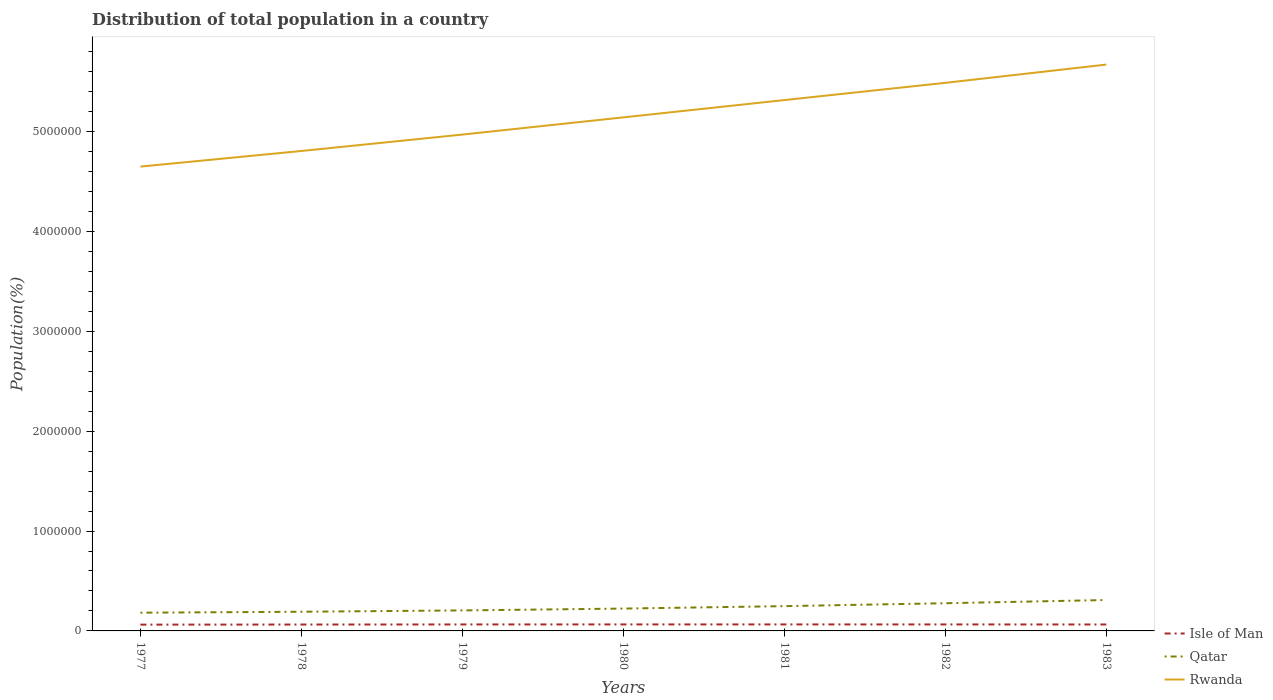How many different coloured lines are there?
Your answer should be very brief. 3. Is the number of lines equal to the number of legend labels?
Offer a terse response. Yes. Across all years, what is the maximum population of in Qatar?
Give a very brief answer. 1.82e+05. In which year was the population of in Qatar maximum?
Your response must be concise. 1977. What is the total population of in Isle of Man in the graph?
Ensure brevity in your answer.  -486. What is the difference between the highest and the second highest population of in Qatar?
Ensure brevity in your answer.  1.27e+05. What is the difference between the highest and the lowest population of in Qatar?
Your answer should be compact. 3. Is the population of in Isle of Man strictly greater than the population of in Qatar over the years?
Your answer should be very brief. Yes. How many years are there in the graph?
Offer a very short reply. 7. Are the values on the major ticks of Y-axis written in scientific E-notation?
Offer a terse response. No. Does the graph contain any zero values?
Offer a terse response. No. Where does the legend appear in the graph?
Provide a short and direct response. Bottom right. How many legend labels are there?
Offer a very short reply. 3. What is the title of the graph?
Your answer should be compact. Distribution of total population in a country. Does "Cote d'Ivoire" appear as one of the legend labels in the graph?
Offer a very short reply. No. What is the label or title of the Y-axis?
Your answer should be compact. Population(%). What is the Population(%) of Isle of Man in 1977?
Give a very brief answer. 6.29e+04. What is the Population(%) of Qatar in 1977?
Your answer should be compact. 1.82e+05. What is the Population(%) in Rwanda in 1977?
Make the answer very short. 4.65e+06. What is the Population(%) of Isle of Man in 1978?
Ensure brevity in your answer.  6.39e+04. What is the Population(%) of Qatar in 1978?
Provide a short and direct response. 1.92e+05. What is the Population(%) of Rwanda in 1978?
Ensure brevity in your answer.  4.80e+06. What is the Population(%) of Isle of Man in 1979?
Make the answer very short. 6.47e+04. What is the Population(%) of Qatar in 1979?
Your response must be concise. 2.05e+05. What is the Population(%) of Rwanda in 1979?
Ensure brevity in your answer.  4.97e+06. What is the Population(%) in Isle of Man in 1980?
Make the answer very short. 6.51e+04. What is the Population(%) of Qatar in 1980?
Keep it short and to the point. 2.24e+05. What is the Population(%) of Rwanda in 1980?
Make the answer very short. 5.14e+06. What is the Population(%) of Isle of Man in 1981?
Give a very brief answer. 6.51e+04. What is the Population(%) in Qatar in 1981?
Ensure brevity in your answer.  2.48e+05. What is the Population(%) of Rwanda in 1981?
Make the answer very short. 5.31e+06. What is the Population(%) in Isle of Man in 1982?
Your response must be concise. 6.48e+04. What is the Population(%) in Qatar in 1982?
Your answer should be compact. 2.77e+05. What is the Population(%) of Rwanda in 1982?
Your response must be concise. 5.49e+06. What is the Population(%) of Isle of Man in 1983?
Offer a terse response. 6.44e+04. What is the Population(%) of Qatar in 1983?
Offer a very short reply. 3.09e+05. What is the Population(%) of Rwanda in 1983?
Offer a very short reply. 5.67e+06. Across all years, what is the maximum Population(%) in Isle of Man?
Provide a succinct answer. 6.51e+04. Across all years, what is the maximum Population(%) of Qatar?
Keep it short and to the point. 3.09e+05. Across all years, what is the maximum Population(%) in Rwanda?
Your answer should be compact. 5.67e+06. Across all years, what is the minimum Population(%) in Isle of Man?
Keep it short and to the point. 6.29e+04. Across all years, what is the minimum Population(%) in Qatar?
Your answer should be very brief. 1.82e+05. Across all years, what is the minimum Population(%) of Rwanda?
Offer a very short reply. 4.65e+06. What is the total Population(%) of Isle of Man in the graph?
Offer a terse response. 4.51e+05. What is the total Population(%) in Qatar in the graph?
Keep it short and to the point. 1.64e+06. What is the total Population(%) in Rwanda in the graph?
Provide a succinct answer. 3.60e+07. What is the difference between the Population(%) of Isle of Man in 1977 and that in 1978?
Make the answer very short. -984. What is the difference between the Population(%) in Qatar in 1977 and that in 1978?
Provide a succinct answer. -9648. What is the difference between the Population(%) of Rwanda in 1977 and that in 1978?
Make the answer very short. -1.56e+05. What is the difference between the Population(%) of Isle of Man in 1977 and that in 1979?
Provide a succinct answer. -1746. What is the difference between the Population(%) in Qatar in 1977 and that in 1979?
Give a very brief answer. -2.29e+04. What is the difference between the Population(%) in Rwanda in 1977 and that in 1979?
Your answer should be compact. -3.21e+05. What is the difference between the Population(%) of Isle of Man in 1977 and that in 1980?
Offer a very short reply. -2174. What is the difference between the Population(%) in Qatar in 1977 and that in 1980?
Your answer should be compact. -4.13e+04. What is the difference between the Population(%) in Rwanda in 1977 and that in 1980?
Your answer should be compact. -4.93e+05. What is the difference between the Population(%) of Isle of Man in 1977 and that in 1981?
Make the answer very short. -2194. What is the difference between the Population(%) of Qatar in 1977 and that in 1981?
Your answer should be very brief. -6.57e+04. What is the difference between the Population(%) of Rwanda in 1977 and that in 1981?
Offer a terse response. -6.66e+05. What is the difference between the Population(%) in Isle of Man in 1977 and that in 1982?
Ensure brevity in your answer.  -1883. What is the difference between the Population(%) in Qatar in 1977 and that in 1982?
Provide a succinct answer. -9.49e+04. What is the difference between the Population(%) of Rwanda in 1977 and that in 1982?
Keep it short and to the point. -8.38e+05. What is the difference between the Population(%) in Isle of Man in 1977 and that in 1983?
Your response must be concise. -1470. What is the difference between the Population(%) in Qatar in 1977 and that in 1983?
Your answer should be very brief. -1.27e+05. What is the difference between the Population(%) in Rwanda in 1977 and that in 1983?
Provide a succinct answer. -1.02e+06. What is the difference between the Population(%) of Isle of Man in 1978 and that in 1979?
Give a very brief answer. -762. What is the difference between the Population(%) of Qatar in 1978 and that in 1979?
Provide a short and direct response. -1.32e+04. What is the difference between the Population(%) in Rwanda in 1978 and that in 1979?
Your answer should be compact. -1.64e+05. What is the difference between the Population(%) in Isle of Man in 1978 and that in 1980?
Offer a very short reply. -1190. What is the difference between the Population(%) of Qatar in 1978 and that in 1980?
Your response must be concise. -3.17e+04. What is the difference between the Population(%) of Rwanda in 1978 and that in 1980?
Keep it short and to the point. -3.36e+05. What is the difference between the Population(%) in Isle of Man in 1978 and that in 1981?
Make the answer very short. -1210. What is the difference between the Population(%) in Qatar in 1978 and that in 1981?
Offer a very short reply. -5.60e+04. What is the difference between the Population(%) in Rwanda in 1978 and that in 1981?
Offer a very short reply. -5.10e+05. What is the difference between the Population(%) of Isle of Man in 1978 and that in 1982?
Offer a terse response. -899. What is the difference between the Population(%) in Qatar in 1978 and that in 1982?
Make the answer very short. -8.52e+04. What is the difference between the Population(%) of Rwanda in 1978 and that in 1982?
Your answer should be compact. -6.82e+05. What is the difference between the Population(%) of Isle of Man in 1978 and that in 1983?
Offer a terse response. -486. What is the difference between the Population(%) of Qatar in 1978 and that in 1983?
Your response must be concise. -1.17e+05. What is the difference between the Population(%) of Rwanda in 1978 and that in 1983?
Keep it short and to the point. -8.65e+05. What is the difference between the Population(%) of Isle of Man in 1979 and that in 1980?
Offer a terse response. -428. What is the difference between the Population(%) of Qatar in 1979 and that in 1980?
Your answer should be very brief. -1.85e+04. What is the difference between the Population(%) of Rwanda in 1979 and that in 1980?
Give a very brief answer. -1.72e+05. What is the difference between the Population(%) of Isle of Man in 1979 and that in 1981?
Offer a terse response. -448. What is the difference between the Population(%) of Qatar in 1979 and that in 1981?
Provide a succinct answer. -4.28e+04. What is the difference between the Population(%) of Rwanda in 1979 and that in 1981?
Your answer should be very brief. -3.45e+05. What is the difference between the Population(%) in Isle of Man in 1979 and that in 1982?
Provide a succinct answer. -137. What is the difference between the Population(%) of Qatar in 1979 and that in 1982?
Offer a terse response. -7.20e+04. What is the difference between the Population(%) in Rwanda in 1979 and that in 1982?
Offer a very short reply. -5.18e+05. What is the difference between the Population(%) in Isle of Man in 1979 and that in 1983?
Your response must be concise. 276. What is the difference between the Population(%) of Qatar in 1979 and that in 1983?
Provide a succinct answer. -1.04e+05. What is the difference between the Population(%) of Rwanda in 1979 and that in 1983?
Make the answer very short. -7.01e+05. What is the difference between the Population(%) of Qatar in 1980 and that in 1981?
Offer a terse response. -2.43e+04. What is the difference between the Population(%) of Rwanda in 1980 and that in 1981?
Provide a succinct answer. -1.73e+05. What is the difference between the Population(%) of Isle of Man in 1980 and that in 1982?
Offer a terse response. 291. What is the difference between the Population(%) of Qatar in 1980 and that in 1982?
Give a very brief answer. -5.35e+04. What is the difference between the Population(%) in Rwanda in 1980 and that in 1982?
Give a very brief answer. -3.46e+05. What is the difference between the Population(%) in Isle of Man in 1980 and that in 1983?
Keep it short and to the point. 704. What is the difference between the Population(%) in Qatar in 1980 and that in 1983?
Offer a terse response. -8.56e+04. What is the difference between the Population(%) of Rwanda in 1980 and that in 1983?
Ensure brevity in your answer.  -5.28e+05. What is the difference between the Population(%) in Isle of Man in 1981 and that in 1982?
Provide a succinct answer. 311. What is the difference between the Population(%) of Qatar in 1981 and that in 1982?
Offer a very short reply. -2.92e+04. What is the difference between the Population(%) in Rwanda in 1981 and that in 1982?
Your response must be concise. -1.73e+05. What is the difference between the Population(%) in Isle of Man in 1981 and that in 1983?
Provide a short and direct response. 724. What is the difference between the Population(%) of Qatar in 1981 and that in 1983?
Your answer should be compact. -6.12e+04. What is the difference between the Population(%) in Rwanda in 1981 and that in 1983?
Provide a short and direct response. -3.55e+05. What is the difference between the Population(%) in Isle of Man in 1982 and that in 1983?
Keep it short and to the point. 413. What is the difference between the Population(%) in Qatar in 1982 and that in 1983?
Make the answer very short. -3.20e+04. What is the difference between the Population(%) of Rwanda in 1982 and that in 1983?
Give a very brief answer. -1.83e+05. What is the difference between the Population(%) in Isle of Man in 1977 and the Population(%) in Qatar in 1978?
Give a very brief answer. -1.29e+05. What is the difference between the Population(%) in Isle of Man in 1977 and the Population(%) in Rwanda in 1978?
Your response must be concise. -4.74e+06. What is the difference between the Population(%) of Qatar in 1977 and the Population(%) of Rwanda in 1978?
Provide a succinct answer. -4.62e+06. What is the difference between the Population(%) in Isle of Man in 1977 and the Population(%) in Qatar in 1979?
Ensure brevity in your answer.  -1.42e+05. What is the difference between the Population(%) in Isle of Man in 1977 and the Population(%) in Rwanda in 1979?
Provide a short and direct response. -4.91e+06. What is the difference between the Population(%) of Qatar in 1977 and the Population(%) of Rwanda in 1979?
Ensure brevity in your answer.  -4.79e+06. What is the difference between the Population(%) of Isle of Man in 1977 and the Population(%) of Qatar in 1980?
Your answer should be compact. -1.61e+05. What is the difference between the Population(%) of Isle of Man in 1977 and the Population(%) of Rwanda in 1980?
Ensure brevity in your answer.  -5.08e+06. What is the difference between the Population(%) of Qatar in 1977 and the Population(%) of Rwanda in 1980?
Make the answer very short. -4.96e+06. What is the difference between the Population(%) in Isle of Man in 1977 and the Population(%) in Qatar in 1981?
Provide a short and direct response. -1.85e+05. What is the difference between the Population(%) of Isle of Man in 1977 and the Population(%) of Rwanda in 1981?
Provide a short and direct response. -5.25e+06. What is the difference between the Population(%) in Qatar in 1977 and the Population(%) in Rwanda in 1981?
Give a very brief answer. -5.13e+06. What is the difference between the Population(%) in Isle of Man in 1977 and the Population(%) in Qatar in 1982?
Offer a very short reply. -2.14e+05. What is the difference between the Population(%) in Isle of Man in 1977 and the Population(%) in Rwanda in 1982?
Provide a succinct answer. -5.42e+06. What is the difference between the Population(%) in Qatar in 1977 and the Population(%) in Rwanda in 1982?
Your answer should be very brief. -5.30e+06. What is the difference between the Population(%) of Isle of Man in 1977 and the Population(%) of Qatar in 1983?
Your answer should be very brief. -2.46e+05. What is the difference between the Population(%) of Isle of Man in 1977 and the Population(%) of Rwanda in 1983?
Provide a short and direct response. -5.61e+06. What is the difference between the Population(%) in Qatar in 1977 and the Population(%) in Rwanda in 1983?
Offer a very short reply. -5.49e+06. What is the difference between the Population(%) in Isle of Man in 1978 and the Population(%) in Qatar in 1979?
Provide a succinct answer. -1.41e+05. What is the difference between the Population(%) of Isle of Man in 1978 and the Population(%) of Rwanda in 1979?
Provide a succinct answer. -4.90e+06. What is the difference between the Population(%) of Qatar in 1978 and the Population(%) of Rwanda in 1979?
Give a very brief answer. -4.78e+06. What is the difference between the Population(%) of Isle of Man in 1978 and the Population(%) of Qatar in 1980?
Keep it short and to the point. -1.60e+05. What is the difference between the Population(%) of Isle of Man in 1978 and the Population(%) of Rwanda in 1980?
Provide a short and direct response. -5.08e+06. What is the difference between the Population(%) of Qatar in 1978 and the Population(%) of Rwanda in 1980?
Provide a short and direct response. -4.95e+06. What is the difference between the Population(%) of Isle of Man in 1978 and the Population(%) of Qatar in 1981?
Your response must be concise. -1.84e+05. What is the difference between the Population(%) in Isle of Man in 1978 and the Population(%) in Rwanda in 1981?
Your response must be concise. -5.25e+06. What is the difference between the Population(%) in Qatar in 1978 and the Population(%) in Rwanda in 1981?
Give a very brief answer. -5.12e+06. What is the difference between the Population(%) in Isle of Man in 1978 and the Population(%) in Qatar in 1982?
Keep it short and to the point. -2.13e+05. What is the difference between the Population(%) of Isle of Man in 1978 and the Population(%) of Rwanda in 1982?
Keep it short and to the point. -5.42e+06. What is the difference between the Population(%) of Qatar in 1978 and the Population(%) of Rwanda in 1982?
Give a very brief answer. -5.29e+06. What is the difference between the Population(%) in Isle of Man in 1978 and the Population(%) in Qatar in 1983?
Your answer should be very brief. -2.45e+05. What is the difference between the Population(%) of Isle of Man in 1978 and the Population(%) of Rwanda in 1983?
Provide a succinct answer. -5.61e+06. What is the difference between the Population(%) in Qatar in 1978 and the Population(%) in Rwanda in 1983?
Offer a terse response. -5.48e+06. What is the difference between the Population(%) of Isle of Man in 1979 and the Population(%) of Qatar in 1980?
Your answer should be very brief. -1.59e+05. What is the difference between the Population(%) of Isle of Man in 1979 and the Population(%) of Rwanda in 1980?
Provide a short and direct response. -5.08e+06. What is the difference between the Population(%) in Qatar in 1979 and the Population(%) in Rwanda in 1980?
Your answer should be very brief. -4.94e+06. What is the difference between the Population(%) of Isle of Man in 1979 and the Population(%) of Qatar in 1981?
Provide a succinct answer. -1.83e+05. What is the difference between the Population(%) of Isle of Man in 1979 and the Population(%) of Rwanda in 1981?
Your response must be concise. -5.25e+06. What is the difference between the Population(%) of Qatar in 1979 and the Population(%) of Rwanda in 1981?
Your answer should be very brief. -5.11e+06. What is the difference between the Population(%) of Isle of Man in 1979 and the Population(%) of Qatar in 1982?
Keep it short and to the point. -2.13e+05. What is the difference between the Population(%) of Isle of Man in 1979 and the Population(%) of Rwanda in 1982?
Provide a succinct answer. -5.42e+06. What is the difference between the Population(%) of Qatar in 1979 and the Population(%) of Rwanda in 1982?
Provide a succinct answer. -5.28e+06. What is the difference between the Population(%) of Isle of Man in 1979 and the Population(%) of Qatar in 1983?
Keep it short and to the point. -2.45e+05. What is the difference between the Population(%) in Isle of Man in 1979 and the Population(%) in Rwanda in 1983?
Your answer should be compact. -5.60e+06. What is the difference between the Population(%) of Qatar in 1979 and the Population(%) of Rwanda in 1983?
Make the answer very short. -5.46e+06. What is the difference between the Population(%) in Isle of Man in 1980 and the Population(%) in Qatar in 1981?
Your response must be concise. -1.83e+05. What is the difference between the Population(%) in Isle of Man in 1980 and the Population(%) in Rwanda in 1981?
Offer a terse response. -5.25e+06. What is the difference between the Population(%) of Qatar in 1980 and the Population(%) of Rwanda in 1981?
Ensure brevity in your answer.  -5.09e+06. What is the difference between the Population(%) of Isle of Man in 1980 and the Population(%) of Qatar in 1982?
Make the answer very short. -2.12e+05. What is the difference between the Population(%) of Isle of Man in 1980 and the Population(%) of Rwanda in 1982?
Provide a short and direct response. -5.42e+06. What is the difference between the Population(%) in Qatar in 1980 and the Population(%) in Rwanda in 1982?
Offer a terse response. -5.26e+06. What is the difference between the Population(%) in Isle of Man in 1980 and the Population(%) in Qatar in 1983?
Provide a short and direct response. -2.44e+05. What is the difference between the Population(%) in Isle of Man in 1980 and the Population(%) in Rwanda in 1983?
Your response must be concise. -5.60e+06. What is the difference between the Population(%) in Qatar in 1980 and the Population(%) in Rwanda in 1983?
Provide a succinct answer. -5.45e+06. What is the difference between the Population(%) of Isle of Man in 1981 and the Population(%) of Qatar in 1982?
Give a very brief answer. -2.12e+05. What is the difference between the Population(%) of Isle of Man in 1981 and the Population(%) of Rwanda in 1982?
Offer a very short reply. -5.42e+06. What is the difference between the Population(%) in Qatar in 1981 and the Population(%) in Rwanda in 1982?
Make the answer very short. -5.24e+06. What is the difference between the Population(%) of Isle of Man in 1981 and the Population(%) of Qatar in 1983?
Keep it short and to the point. -2.44e+05. What is the difference between the Population(%) in Isle of Man in 1981 and the Population(%) in Rwanda in 1983?
Ensure brevity in your answer.  -5.60e+06. What is the difference between the Population(%) of Qatar in 1981 and the Population(%) of Rwanda in 1983?
Offer a terse response. -5.42e+06. What is the difference between the Population(%) in Isle of Man in 1982 and the Population(%) in Qatar in 1983?
Keep it short and to the point. -2.44e+05. What is the difference between the Population(%) in Isle of Man in 1982 and the Population(%) in Rwanda in 1983?
Ensure brevity in your answer.  -5.60e+06. What is the difference between the Population(%) in Qatar in 1982 and the Population(%) in Rwanda in 1983?
Offer a very short reply. -5.39e+06. What is the average Population(%) of Isle of Man per year?
Your answer should be compact. 6.44e+04. What is the average Population(%) in Qatar per year?
Your answer should be compact. 2.34e+05. What is the average Population(%) of Rwanda per year?
Make the answer very short. 5.15e+06. In the year 1977, what is the difference between the Population(%) in Isle of Man and Population(%) in Qatar?
Provide a short and direct response. -1.19e+05. In the year 1977, what is the difference between the Population(%) of Isle of Man and Population(%) of Rwanda?
Offer a very short reply. -4.59e+06. In the year 1977, what is the difference between the Population(%) of Qatar and Population(%) of Rwanda?
Your answer should be compact. -4.47e+06. In the year 1978, what is the difference between the Population(%) of Isle of Man and Population(%) of Qatar?
Your response must be concise. -1.28e+05. In the year 1978, what is the difference between the Population(%) in Isle of Man and Population(%) in Rwanda?
Offer a very short reply. -4.74e+06. In the year 1978, what is the difference between the Population(%) of Qatar and Population(%) of Rwanda?
Offer a terse response. -4.61e+06. In the year 1979, what is the difference between the Population(%) in Isle of Man and Population(%) in Qatar?
Keep it short and to the point. -1.41e+05. In the year 1979, what is the difference between the Population(%) in Isle of Man and Population(%) in Rwanda?
Your answer should be very brief. -4.90e+06. In the year 1979, what is the difference between the Population(%) in Qatar and Population(%) in Rwanda?
Give a very brief answer. -4.76e+06. In the year 1980, what is the difference between the Population(%) in Isle of Man and Population(%) in Qatar?
Your answer should be very brief. -1.59e+05. In the year 1980, what is the difference between the Population(%) in Isle of Man and Population(%) in Rwanda?
Keep it short and to the point. -5.08e+06. In the year 1980, what is the difference between the Population(%) in Qatar and Population(%) in Rwanda?
Offer a very short reply. -4.92e+06. In the year 1981, what is the difference between the Population(%) in Isle of Man and Population(%) in Qatar?
Offer a very short reply. -1.83e+05. In the year 1981, what is the difference between the Population(%) of Isle of Man and Population(%) of Rwanda?
Make the answer very short. -5.25e+06. In the year 1981, what is the difference between the Population(%) in Qatar and Population(%) in Rwanda?
Give a very brief answer. -5.07e+06. In the year 1982, what is the difference between the Population(%) of Isle of Man and Population(%) of Qatar?
Keep it short and to the point. -2.12e+05. In the year 1982, what is the difference between the Population(%) in Isle of Man and Population(%) in Rwanda?
Offer a very short reply. -5.42e+06. In the year 1982, what is the difference between the Population(%) of Qatar and Population(%) of Rwanda?
Provide a succinct answer. -5.21e+06. In the year 1983, what is the difference between the Population(%) of Isle of Man and Population(%) of Qatar?
Your response must be concise. -2.45e+05. In the year 1983, what is the difference between the Population(%) in Isle of Man and Population(%) in Rwanda?
Ensure brevity in your answer.  -5.60e+06. In the year 1983, what is the difference between the Population(%) in Qatar and Population(%) in Rwanda?
Keep it short and to the point. -5.36e+06. What is the ratio of the Population(%) in Isle of Man in 1977 to that in 1978?
Ensure brevity in your answer.  0.98. What is the ratio of the Population(%) in Qatar in 1977 to that in 1978?
Make the answer very short. 0.95. What is the ratio of the Population(%) in Rwanda in 1977 to that in 1978?
Your answer should be very brief. 0.97. What is the ratio of the Population(%) in Isle of Man in 1977 to that in 1979?
Give a very brief answer. 0.97. What is the ratio of the Population(%) of Qatar in 1977 to that in 1979?
Your answer should be compact. 0.89. What is the ratio of the Population(%) of Rwanda in 1977 to that in 1979?
Your answer should be compact. 0.94. What is the ratio of the Population(%) of Isle of Man in 1977 to that in 1980?
Your answer should be compact. 0.97. What is the ratio of the Population(%) of Qatar in 1977 to that in 1980?
Provide a short and direct response. 0.82. What is the ratio of the Population(%) in Rwanda in 1977 to that in 1980?
Ensure brevity in your answer.  0.9. What is the ratio of the Population(%) of Isle of Man in 1977 to that in 1981?
Your answer should be compact. 0.97. What is the ratio of the Population(%) in Qatar in 1977 to that in 1981?
Your answer should be compact. 0.74. What is the ratio of the Population(%) of Rwanda in 1977 to that in 1981?
Offer a very short reply. 0.87. What is the ratio of the Population(%) in Isle of Man in 1977 to that in 1982?
Provide a succinct answer. 0.97. What is the ratio of the Population(%) in Qatar in 1977 to that in 1982?
Make the answer very short. 0.66. What is the ratio of the Population(%) in Rwanda in 1977 to that in 1982?
Offer a very short reply. 0.85. What is the ratio of the Population(%) of Isle of Man in 1977 to that in 1983?
Your answer should be very brief. 0.98. What is the ratio of the Population(%) of Qatar in 1977 to that in 1983?
Offer a very short reply. 0.59. What is the ratio of the Population(%) in Rwanda in 1977 to that in 1983?
Provide a succinct answer. 0.82. What is the ratio of the Population(%) of Isle of Man in 1978 to that in 1979?
Your answer should be very brief. 0.99. What is the ratio of the Population(%) in Qatar in 1978 to that in 1979?
Keep it short and to the point. 0.94. What is the ratio of the Population(%) of Rwanda in 1978 to that in 1979?
Provide a short and direct response. 0.97. What is the ratio of the Population(%) in Isle of Man in 1978 to that in 1980?
Your answer should be compact. 0.98. What is the ratio of the Population(%) in Qatar in 1978 to that in 1980?
Your response must be concise. 0.86. What is the ratio of the Population(%) in Rwanda in 1978 to that in 1980?
Your answer should be very brief. 0.93. What is the ratio of the Population(%) in Isle of Man in 1978 to that in 1981?
Offer a terse response. 0.98. What is the ratio of the Population(%) of Qatar in 1978 to that in 1981?
Ensure brevity in your answer.  0.77. What is the ratio of the Population(%) of Rwanda in 1978 to that in 1981?
Provide a short and direct response. 0.9. What is the ratio of the Population(%) in Isle of Man in 1978 to that in 1982?
Offer a terse response. 0.99. What is the ratio of the Population(%) in Qatar in 1978 to that in 1982?
Provide a short and direct response. 0.69. What is the ratio of the Population(%) of Rwanda in 1978 to that in 1982?
Your answer should be very brief. 0.88. What is the ratio of the Population(%) of Qatar in 1978 to that in 1983?
Your answer should be very brief. 0.62. What is the ratio of the Population(%) in Rwanda in 1978 to that in 1983?
Ensure brevity in your answer.  0.85. What is the ratio of the Population(%) in Isle of Man in 1979 to that in 1980?
Your response must be concise. 0.99. What is the ratio of the Population(%) in Qatar in 1979 to that in 1980?
Offer a very short reply. 0.92. What is the ratio of the Population(%) of Rwanda in 1979 to that in 1980?
Your response must be concise. 0.97. What is the ratio of the Population(%) of Qatar in 1979 to that in 1981?
Your answer should be very brief. 0.83. What is the ratio of the Population(%) of Rwanda in 1979 to that in 1981?
Offer a terse response. 0.94. What is the ratio of the Population(%) in Qatar in 1979 to that in 1982?
Offer a very short reply. 0.74. What is the ratio of the Population(%) in Rwanda in 1979 to that in 1982?
Provide a succinct answer. 0.91. What is the ratio of the Population(%) in Qatar in 1979 to that in 1983?
Keep it short and to the point. 0.66. What is the ratio of the Population(%) in Rwanda in 1979 to that in 1983?
Provide a short and direct response. 0.88. What is the ratio of the Population(%) of Qatar in 1980 to that in 1981?
Give a very brief answer. 0.9. What is the ratio of the Population(%) of Rwanda in 1980 to that in 1981?
Your answer should be very brief. 0.97. What is the ratio of the Population(%) in Isle of Man in 1980 to that in 1982?
Provide a succinct answer. 1. What is the ratio of the Population(%) in Qatar in 1980 to that in 1982?
Your answer should be very brief. 0.81. What is the ratio of the Population(%) of Rwanda in 1980 to that in 1982?
Your answer should be very brief. 0.94. What is the ratio of the Population(%) in Isle of Man in 1980 to that in 1983?
Give a very brief answer. 1.01. What is the ratio of the Population(%) of Qatar in 1980 to that in 1983?
Provide a short and direct response. 0.72. What is the ratio of the Population(%) in Rwanda in 1980 to that in 1983?
Your answer should be compact. 0.91. What is the ratio of the Population(%) of Qatar in 1981 to that in 1982?
Provide a short and direct response. 0.89. What is the ratio of the Population(%) in Rwanda in 1981 to that in 1982?
Provide a short and direct response. 0.97. What is the ratio of the Population(%) in Isle of Man in 1981 to that in 1983?
Provide a short and direct response. 1.01. What is the ratio of the Population(%) of Qatar in 1981 to that in 1983?
Offer a very short reply. 0.8. What is the ratio of the Population(%) in Rwanda in 1981 to that in 1983?
Keep it short and to the point. 0.94. What is the ratio of the Population(%) in Isle of Man in 1982 to that in 1983?
Ensure brevity in your answer.  1.01. What is the ratio of the Population(%) of Qatar in 1982 to that in 1983?
Ensure brevity in your answer.  0.9. What is the ratio of the Population(%) of Rwanda in 1982 to that in 1983?
Your answer should be very brief. 0.97. What is the difference between the highest and the second highest Population(%) of Isle of Man?
Offer a very short reply. 20. What is the difference between the highest and the second highest Population(%) of Qatar?
Your answer should be very brief. 3.20e+04. What is the difference between the highest and the second highest Population(%) of Rwanda?
Provide a succinct answer. 1.83e+05. What is the difference between the highest and the lowest Population(%) of Isle of Man?
Give a very brief answer. 2194. What is the difference between the highest and the lowest Population(%) in Qatar?
Your answer should be compact. 1.27e+05. What is the difference between the highest and the lowest Population(%) of Rwanda?
Give a very brief answer. 1.02e+06. 